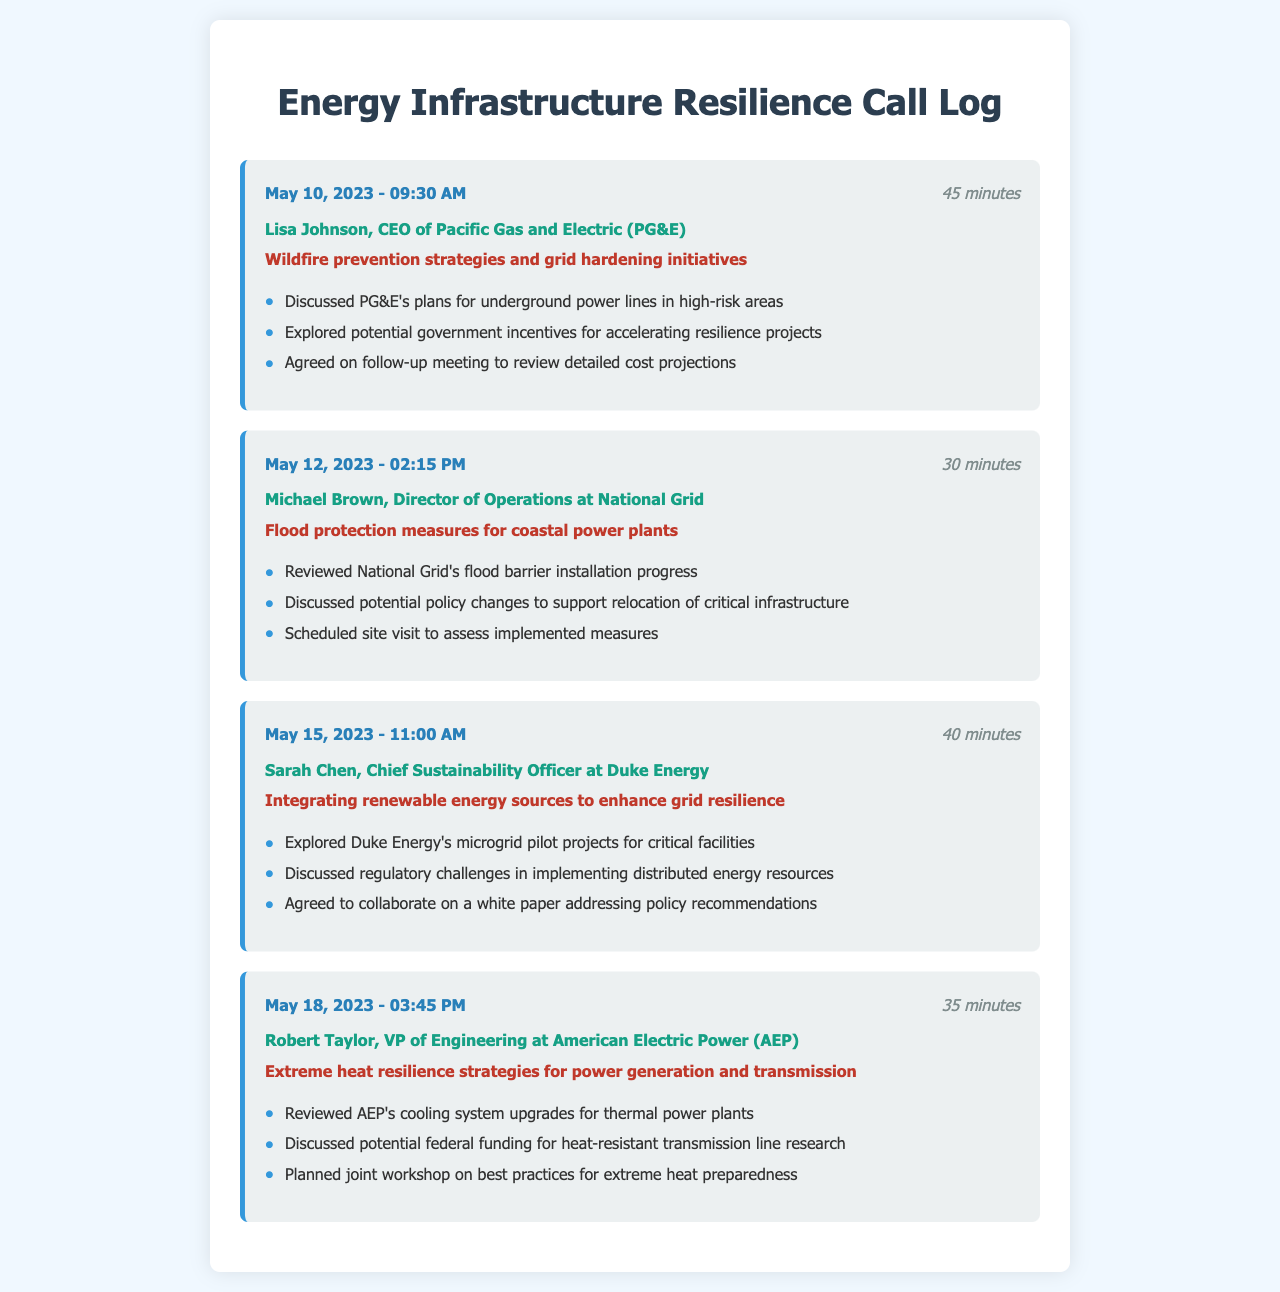What is the date of the call with Lisa Johnson? The date is provided in the call entry for Lisa Johnson.
Answer: May 10, 2023 How long was the call with Michael Brown? The duration of the call with Michael Brown is mentioned in the call entry.
Answer: 30 minutes What company does Sarah Chen represent? The document specifies the contact information for Sarah Chen, including her company.
Answer: Duke Energy What was a key topic discussed in the call with Robert Taylor? The key topic is noted in the call entry for Robert Taylor.
Answer: Extreme heat resilience strategies How many calls were made regarding flood protection measures? The document lists calls, among which flood protection measures is a topic, allowing us to count.
Answer: One call What was discussed in the follow-up meeting planned with Lisa Johnson? The document mentions the agenda for the follow-up meeting in the call entry.
Answer: Review detailed cost projections What incentive was discussed during the call with Lisa Johnson? The document highlights potential government incentives mentioned in the conversation.
Answer: Accelerating resilience projects What is the purpose of the planned joint workshop with Robert Taylor? The purpose is stated in the context of the call with Robert Taylor.
Answer: Best practices for extreme heat preparedness What type of projects did Sarah Chen's call focus on? The call with Sarah Chen is focused on a specific type of project as indicated in the entry.
Answer: Microgrid pilot projects 